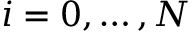Convert formula to latex. <formula><loc_0><loc_0><loc_500><loc_500>i = 0 , \dots , N</formula> 